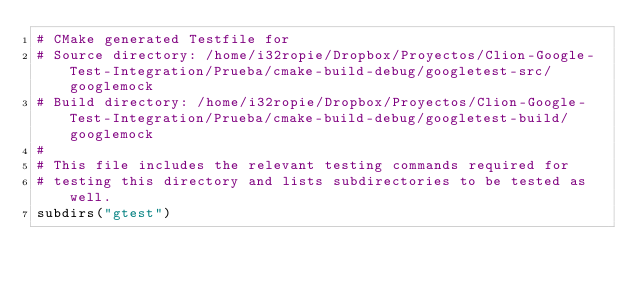Convert code to text. <code><loc_0><loc_0><loc_500><loc_500><_CMake_># CMake generated Testfile for 
# Source directory: /home/i32ropie/Dropbox/Proyectos/Clion-Google-Test-Integration/Prueba/cmake-build-debug/googletest-src/googlemock
# Build directory: /home/i32ropie/Dropbox/Proyectos/Clion-Google-Test-Integration/Prueba/cmake-build-debug/googletest-build/googlemock
# 
# This file includes the relevant testing commands required for 
# testing this directory and lists subdirectories to be tested as well.
subdirs("gtest")
</code> 